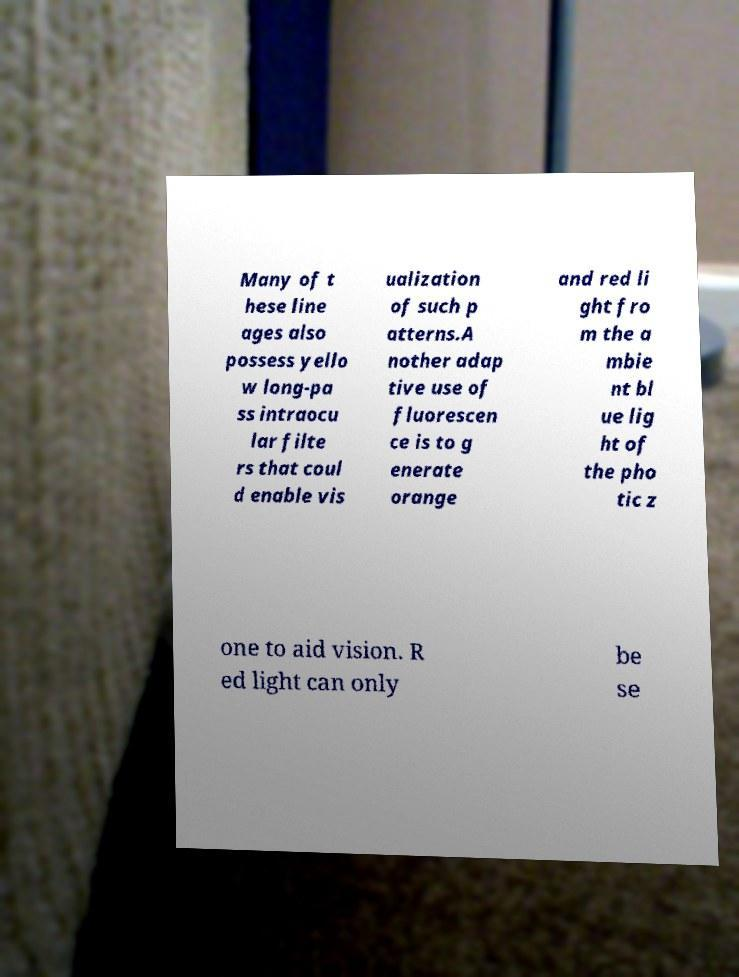Please read and relay the text visible in this image. What does it say? Many of t hese line ages also possess yello w long-pa ss intraocu lar filte rs that coul d enable vis ualization of such p atterns.A nother adap tive use of fluorescen ce is to g enerate orange and red li ght fro m the a mbie nt bl ue lig ht of the pho tic z one to aid vision. R ed light can only be se 